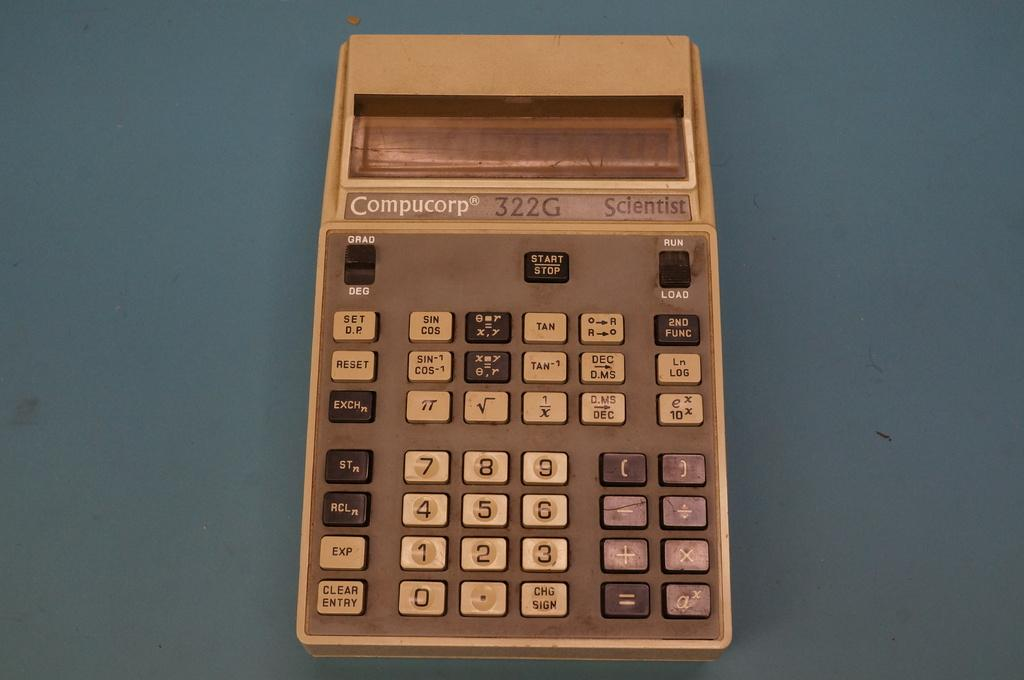Provide a one-sentence caption for the provided image. An old Compucorp calculator has a plain digital readout display. 